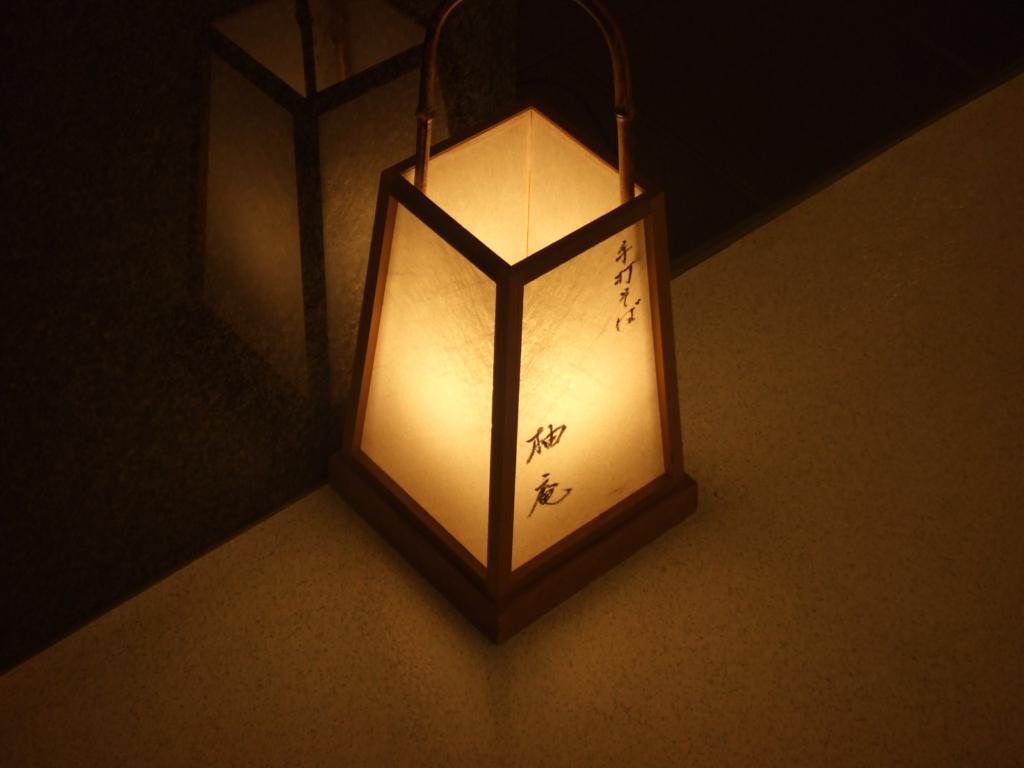What is the main object in the image? There is a light object in the image. Can you describe the location of the light object? The light object is kept on a surface. How many boys are ringing the bells in the image? There are no boys or bells present in the image. 